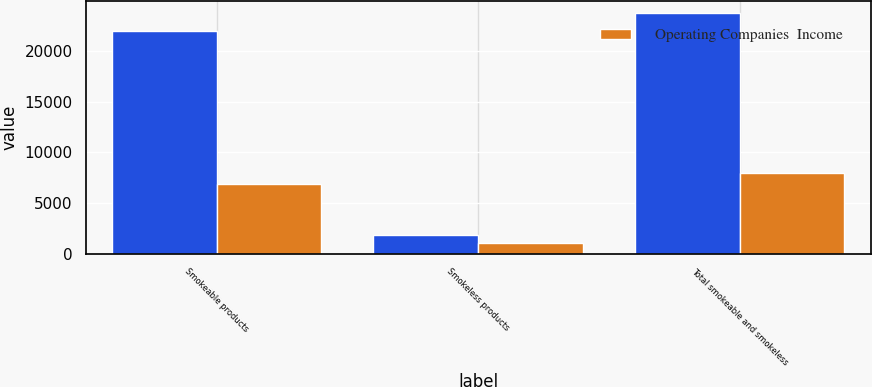<chart> <loc_0><loc_0><loc_500><loc_500><stacked_bar_chart><ecel><fcel>Smokeable products<fcel>Smokeless products<fcel>Total smokeable and smokeless<nl><fcel>nan<fcel>21939<fcel>1809<fcel>23748<nl><fcel>Operating Companies  Income<fcel>6873<fcel>1061<fcel>7934<nl></chart> 